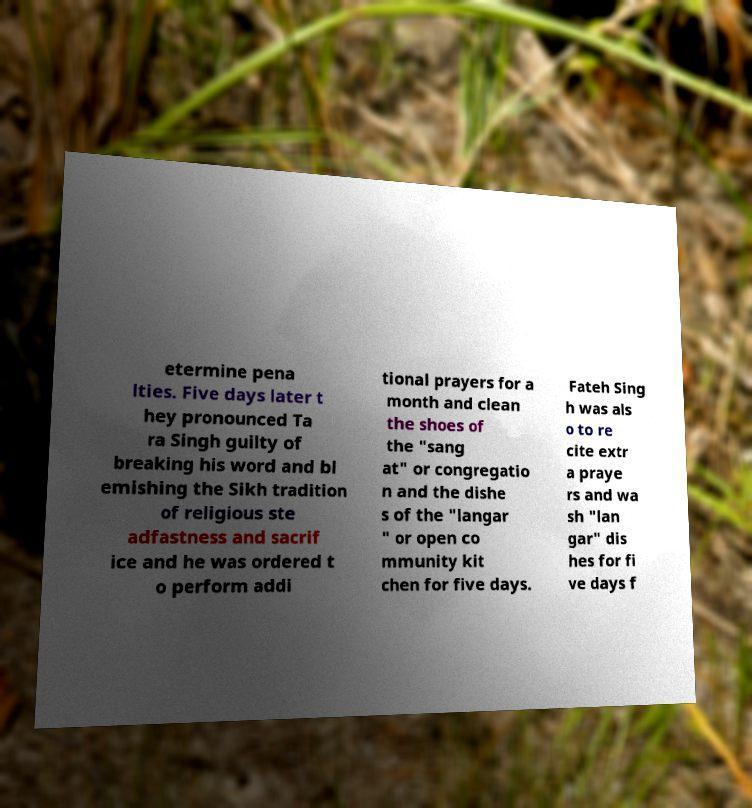Could you extract and type out the text from this image? etermine pena lties. Five days later t hey pronounced Ta ra Singh guilty of breaking his word and bl emishing the Sikh tradition of religious ste adfastness and sacrif ice and he was ordered t o perform addi tional prayers for a month and clean the shoes of the "sang at" or congregatio n and the dishe s of the "langar " or open co mmunity kit chen for five days. Fateh Sing h was als o to re cite extr a praye rs and wa sh "lan gar" dis hes for fi ve days f 